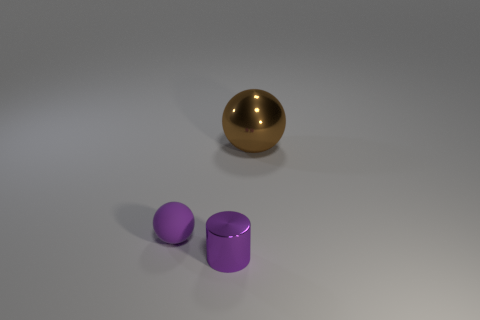Is there anything else that has the same material as the tiny purple ball?
Your response must be concise. No. What number of objects are things in front of the large thing or brown metal objects?
Keep it short and to the point. 3. There is a purple thing that is in front of the tiny rubber object on the left side of the small cylinder; what is its shape?
Ensure brevity in your answer.  Cylinder. Is there a yellow sphere that has the same size as the purple matte thing?
Provide a short and direct response. No. Is the number of cyan matte cubes greater than the number of tiny purple cylinders?
Keep it short and to the point. No. Does the ball in front of the metallic sphere have the same size as the thing on the right side of the small metallic thing?
Offer a terse response. No. What number of balls are on the right side of the small purple rubber ball and in front of the large brown ball?
Give a very brief answer. 0. There is another object that is the same shape as the tiny purple matte object; what color is it?
Offer a very short reply. Brown. Is the number of big brown metal things less than the number of purple objects?
Offer a very short reply. Yes. Is the size of the metal sphere the same as the purple thing that is on the right side of the rubber object?
Offer a very short reply. No. 